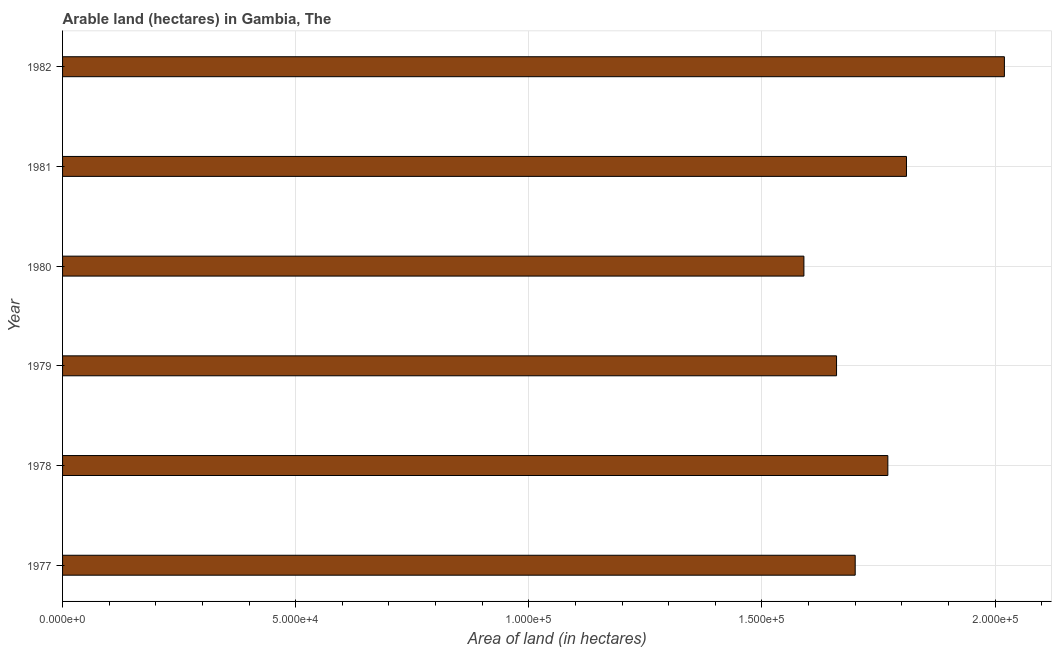What is the title of the graph?
Give a very brief answer. Arable land (hectares) in Gambia, The. What is the label or title of the X-axis?
Offer a very short reply. Area of land (in hectares). What is the area of land in 1982?
Ensure brevity in your answer.  2.02e+05. Across all years, what is the maximum area of land?
Provide a succinct answer. 2.02e+05. Across all years, what is the minimum area of land?
Ensure brevity in your answer.  1.59e+05. What is the sum of the area of land?
Your answer should be very brief. 1.06e+06. What is the difference between the area of land in 1981 and 1982?
Your answer should be very brief. -2.10e+04. What is the average area of land per year?
Provide a short and direct response. 1.76e+05. What is the median area of land?
Ensure brevity in your answer.  1.74e+05. What is the ratio of the area of land in 1977 to that in 1981?
Ensure brevity in your answer.  0.94. Is the area of land in 1979 less than that in 1981?
Provide a succinct answer. Yes. What is the difference between the highest and the second highest area of land?
Provide a short and direct response. 2.10e+04. What is the difference between the highest and the lowest area of land?
Offer a terse response. 4.30e+04. How many bars are there?
Make the answer very short. 6. Are all the bars in the graph horizontal?
Your response must be concise. Yes. How many years are there in the graph?
Provide a succinct answer. 6. What is the difference between two consecutive major ticks on the X-axis?
Offer a terse response. 5.00e+04. What is the Area of land (in hectares) of 1978?
Ensure brevity in your answer.  1.77e+05. What is the Area of land (in hectares) of 1979?
Keep it short and to the point. 1.66e+05. What is the Area of land (in hectares) in 1980?
Make the answer very short. 1.59e+05. What is the Area of land (in hectares) in 1981?
Offer a very short reply. 1.81e+05. What is the Area of land (in hectares) of 1982?
Provide a succinct answer. 2.02e+05. What is the difference between the Area of land (in hectares) in 1977 and 1978?
Provide a succinct answer. -7000. What is the difference between the Area of land (in hectares) in 1977 and 1979?
Ensure brevity in your answer.  4000. What is the difference between the Area of land (in hectares) in 1977 and 1980?
Make the answer very short. 1.10e+04. What is the difference between the Area of land (in hectares) in 1977 and 1981?
Make the answer very short. -1.10e+04. What is the difference between the Area of land (in hectares) in 1977 and 1982?
Keep it short and to the point. -3.20e+04. What is the difference between the Area of land (in hectares) in 1978 and 1979?
Keep it short and to the point. 1.10e+04. What is the difference between the Area of land (in hectares) in 1978 and 1980?
Offer a very short reply. 1.80e+04. What is the difference between the Area of land (in hectares) in 1978 and 1981?
Offer a very short reply. -4000. What is the difference between the Area of land (in hectares) in 1978 and 1982?
Keep it short and to the point. -2.50e+04. What is the difference between the Area of land (in hectares) in 1979 and 1980?
Your answer should be very brief. 7000. What is the difference between the Area of land (in hectares) in 1979 and 1981?
Offer a terse response. -1.50e+04. What is the difference between the Area of land (in hectares) in 1979 and 1982?
Ensure brevity in your answer.  -3.60e+04. What is the difference between the Area of land (in hectares) in 1980 and 1981?
Make the answer very short. -2.20e+04. What is the difference between the Area of land (in hectares) in 1980 and 1982?
Your response must be concise. -4.30e+04. What is the difference between the Area of land (in hectares) in 1981 and 1982?
Make the answer very short. -2.10e+04. What is the ratio of the Area of land (in hectares) in 1977 to that in 1979?
Your answer should be compact. 1.02. What is the ratio of the Area of land (in hectares) in 1977 to that in 1980?
Offer a terse response. 1.07. What is the ratio of the Area of land (in hectares) in 1977 to that in 1981?
Keep it short and to the point. 0.94. What is the ratio of the Area of land (in hectares) in 1977 to that in 1982?
Keep it short and to the point. 0.84. What is the ratio of the Area of land (in hectares) in 1978 to that in 1979?
Offer a terse response. 1.07. What is the ratio of the Area of land (in hectares) in 1978 to that in 1980?
Keep it short and to the point. 1.11. What is the ratio of the Area of land (in hectares) in 1978 to that in 1982?
Provide a short and direct response. 0.88. What is the ratio of the Area of land (in hectares) in 1979 to that in 1980?
Give a very brief answer. 1.04. What is the ratio of the Area of land (in hectares) in 1979 to that in 1981?
Offer a very short reply. 0.92. What is the ratio of the Area of land (in hectares) in 1979 to that in 1982?
Ensure brevity in your answer.  0.82. What is the ratio of the Area of land (in hectares) in 1980 to that in 1981?
Offer a terse response. 0.88. What is the ratio of the Area of land (in hectares) in 1980 to that in 1982?
Your answer should be very brief. 0.79. What is the ratio of the Area of land (in hectares) in 1981 to that in 1982?
Give a very brief answer. 0.9. 